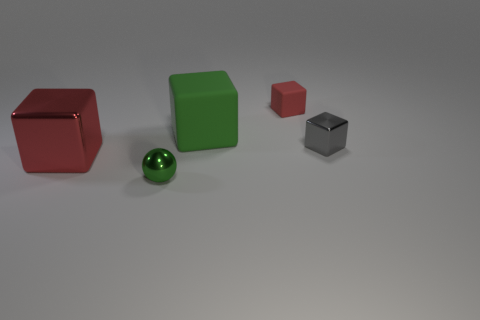Is the number of metallic blocks right of the big rubber block greater than the number of metallic things to the right of the small matte block?
Provide a succinct answer. No. Are there any other things that have the same color as the tiny matte block?
Offer a terse response. Yes. What is the material of the green object that is on the right side of the green ball?
Offer a very short reply. Rubber. Is the size of the red rubber cube the same as the gray shiny block?
Your answer should be very brief. Yes. How many other objects are there of the same size as the red rubber object?
Your answer should be compact. 2. Is the color of the tiny rubber object the same as the large shiny block?
Provide a short and direct response. Yes. The tiny metal thing left of the shiny object to the right of the red block that is to the right of the big red object is what shape?
Offer a terse response. Sphere. What number of things are either shiny things that are left of the green metal sphere or small metallic objects that are on the left side of the small red matte block?
Your answer should be compact. 2. There is a red cube that is behind the large cube that is behind the gray thing; what is its size?
Your answer should be compact. Small. Is the color of the cube that is behind the green rubber cube the same as the big metallic block?
Offer a terse response. Yes. 